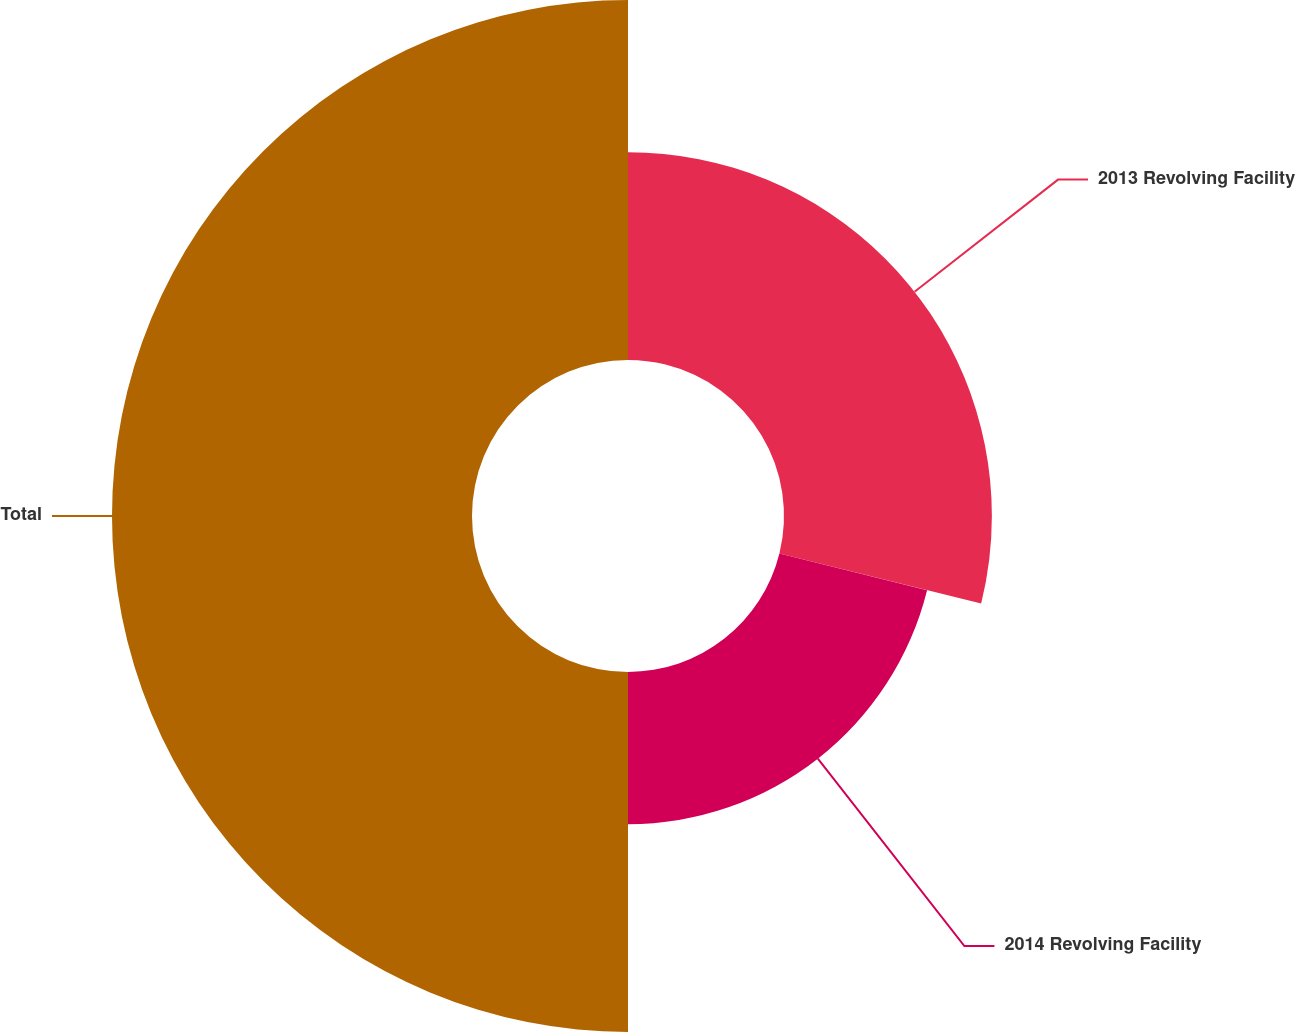Convert chart. <chart><loc_0><loc_0><loc_500><loc_500><pie_chart><fcel>2013 Revolving Facility<fcel>2014 Revolving Facility<fcel>Total<nl><fcel>28.87%<fcel>21.13%<fcel>50.0%<nl></chart> 